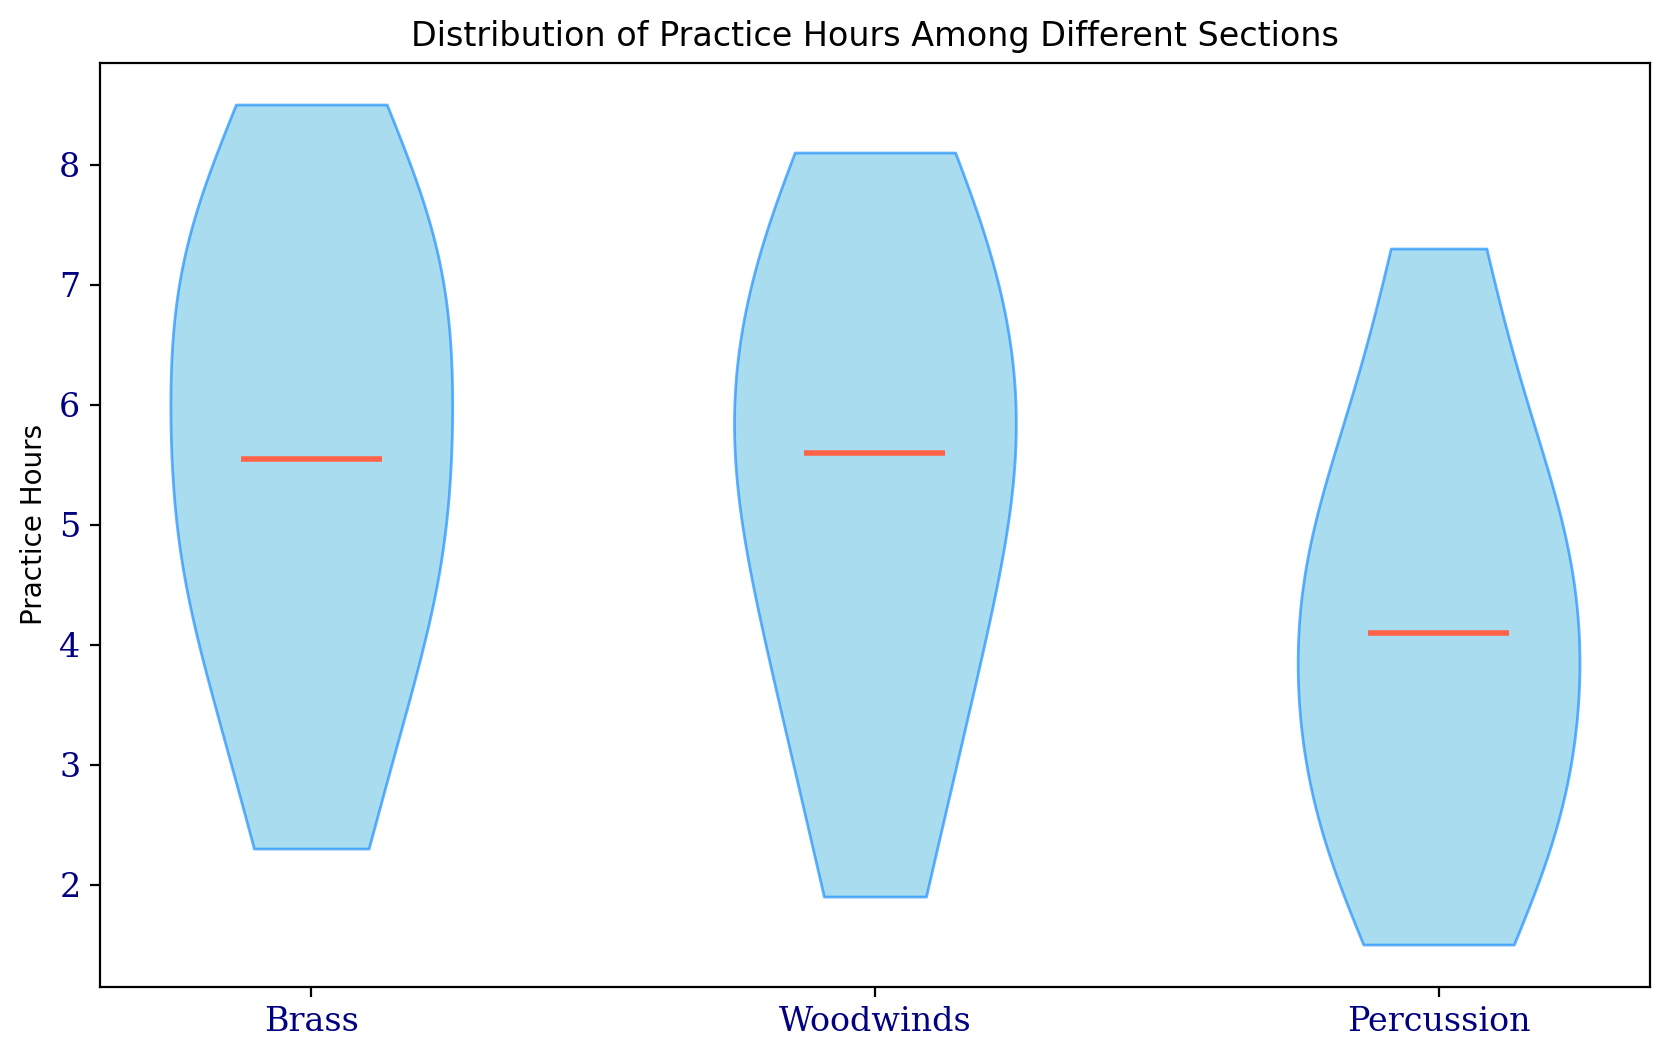What is the median practice hours for the brass section? The violin plot has a line indicating medians. Find the line inside the brass section's shape to determine the median.
Answer: 6.0 Which section has the highest median practice hours? Compare the median lines across the three sections (Brass, Woodwinds, Percussion). The section with the highest line represents the highest median.
Answer: Woodwinds Between the brass and percussion sections, which one has a wider range of practice hours? Compare the vertical spread (range) of the violin shapes of brass and percussion sections. The section with the larger vertical span has the wider range.
Answer: Brass How do the medians of the brass and woodwinds sections compare? Identify the heights of the median lines in the brass and woodwinds sections and compare them.
Answer: Woodwinds' median is higher than Brass' What is the difference between the median practice hours of percussion and brass sections? Subtract the median practice hours of brass from the median practice hours of percussion by identifying their median lines.
Answer: 0.0 Are any sections' practice hours distributions skewed? If so, which ones? Look for asymmetric shapes in the violin plots to determine skewness.
Answer: Percussion Which section shows the greatest spread in practice hours? Identify the section with the widest violin plot in terms of vertical spread, indicating the greatest spread in practice hours.
Answer: Brass Does the distribution of practice hours suggest that brass players practice more consistently than percussion players? Compare the evenness and spread of the violin plots for brass and percussion. Consistency is indicated by a narrower, more centered shape.
Answer: Yes Which section's practice hours distribution is closest to symmetric? Symmetry can be observed visually by noting how evenly the shapes of the violin plots are mirrored about their center.
Answer: Woodwinds How does the width of the violin plot for woodwinds compare to that for brass? Examine the horizontal width of the violin plots for each section. Wider plots indicate more variability in practice hours.
Answer: Narrower 